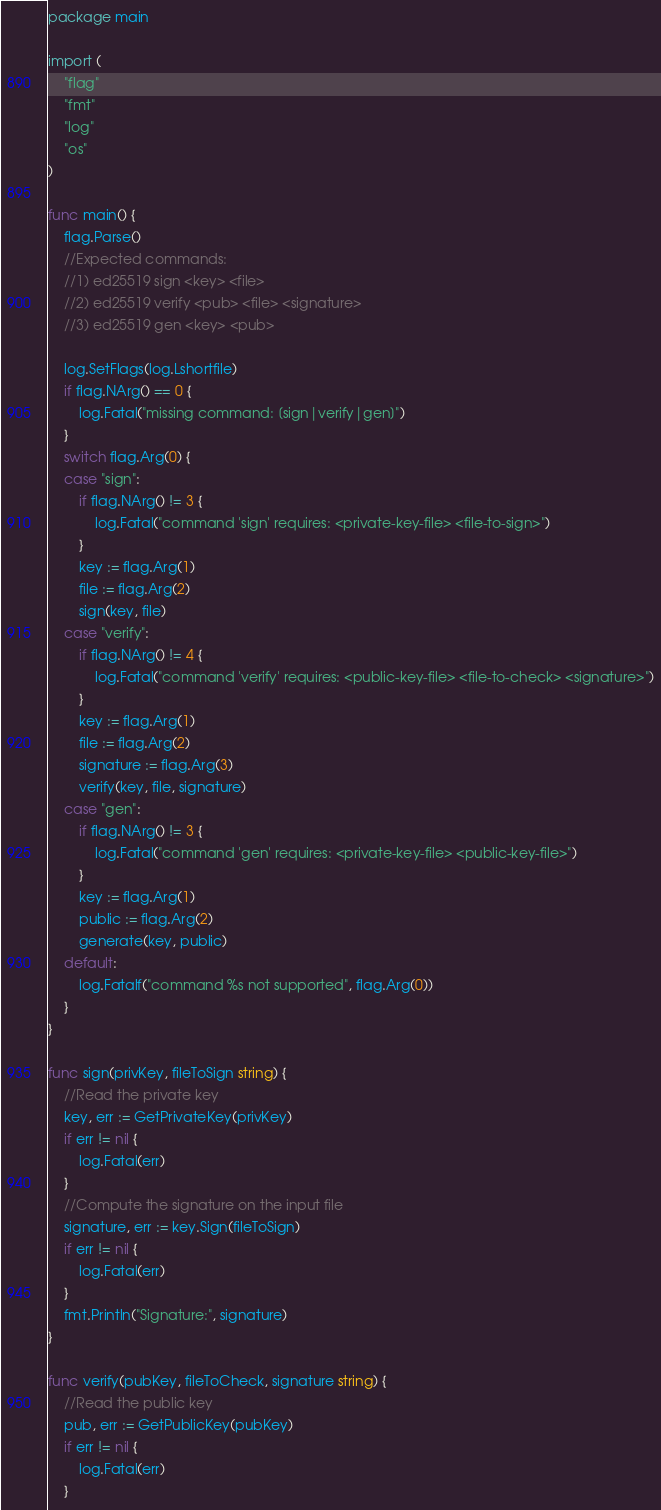<code> <loc_0><loc_0><loc_500><loc_500><_Go_>package main

import (
	"flag"
	"fmt"
	"log"
	"os"
)

func main() {
	flag.Parse()
	//Expected commands:
	//1) ed25519 sign <key> <file>
	//2) ed25519 verify <pub> <file> <signature>
	//3) ed25519 gen <key> <pub>

	log.SetFlags(log.Lshortfile)
	if flag.NArg() == 0 {
		log.Fatal("missing command: [sign|verify|gen]")
	}
	switch flag.Arg(0) {
	case "sign":
		if flag.NArg() != 3 {
			log.Fatal("command 'sign' requires: <private-key-file> <file-to-sign>")
		}
		key := flag.Arg(1)
		file := flag.Arg(2)
		sign(key, file)
	case "verify":
		if flag.NArg() != 4 {
			log.Fatal("command 'verify' requires: <public-key-file> <file-to-check> <signature>")
		}
		key := flag.Arg(1)
		file := flag.Arg(2)
		signature := flag.Arg(3)
		verify(key, file, signature)
	case "gen":
		if flag.NArg() != 3 {
			log.Fatal("command 'gen' requires: <private-key-file> <public-key-file>")
		}
		key := flag.Arg(1)
		public := flag.Arg(2)
		generate(key, public)
	default:
		log.Fatalf("command %s not supported", flag.Arg(0))
	}
}

func sign(privKey, fileToSign string) {
	//Read the private key
	key, err := GetPrivateKey(privKey)
	if err != nil {
		log.Fatal(err)
	}
	//Compute the signature on the input file
	signature, err := key.Sign(fileToSign)
	if err != nil {
		log.Fatal(err)
	}
	fmt.Println("Signature:", signature)
}

func verify(pubKey, fileToCheck, signature string) {
	//Read the public key
	pub, err := GetPublicKey(pubKey)
	if err != nil {
		log.Fatal(err)
	}</code> 